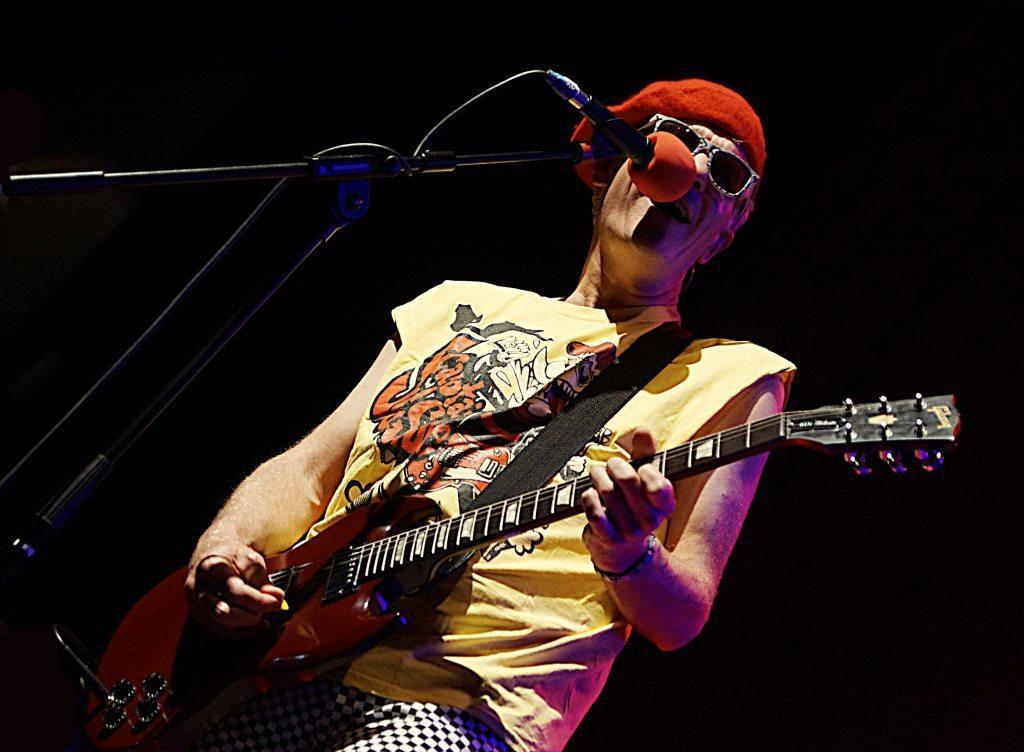Can you describe this image briefly? In this image a man is singing and playing guitar in front of microphone. 